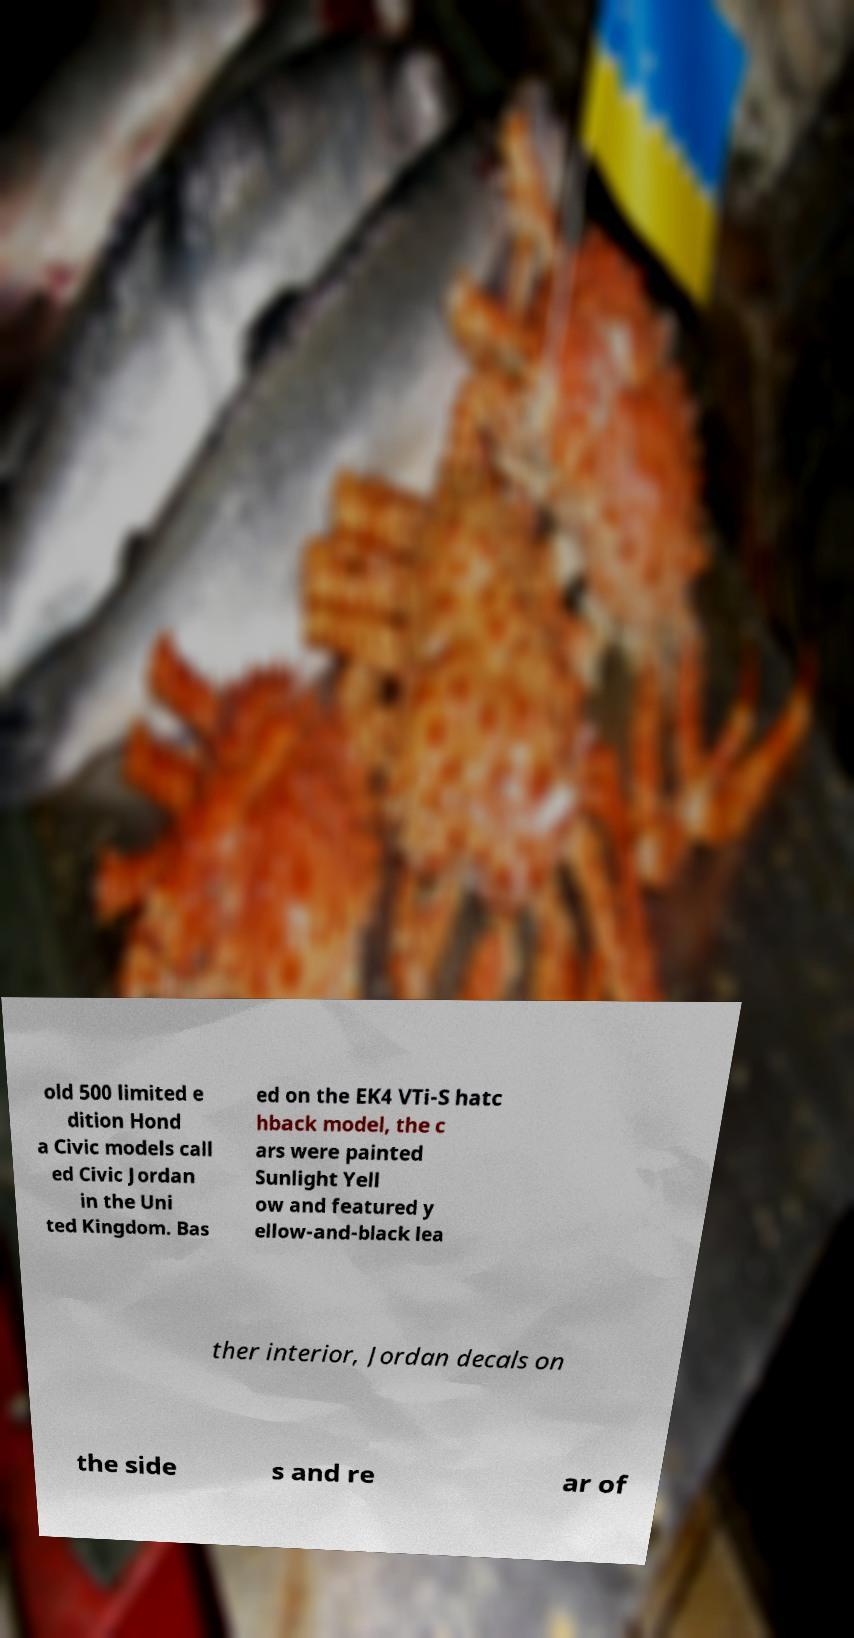Please read and relay the text visible in this image. What does it say? old 500 limited e dition Hond a Civic models call ed Civic Jordan in the Uni ted Kingdom. Bas ed on the EK4 VTi-S hatc hback model, the c ars were painted Sunlight Yell ow and featured y ellow-and-black lea ther interior, Jordan decals on the side s and re ar of 